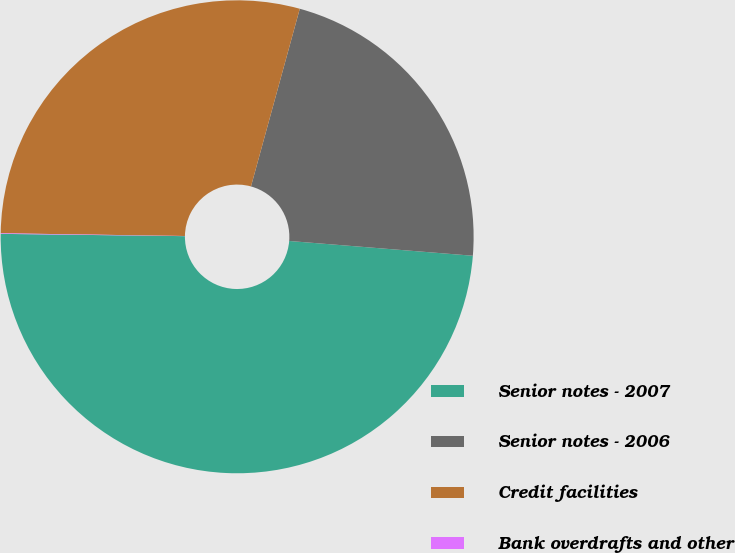Convert chart to OTSL. <chart><loc_0><loc_0><loc_500><loc_500><pie_chart><fcel>Senior notes - 2007<fcel>Senior notes - 2006<fcel>Credit facilities<fcel>Bank overdrafts and other<nl><fcel>48.92%<fcel>22.01%<fcel>29.03%<fcel>0.04%<nl></chart> 